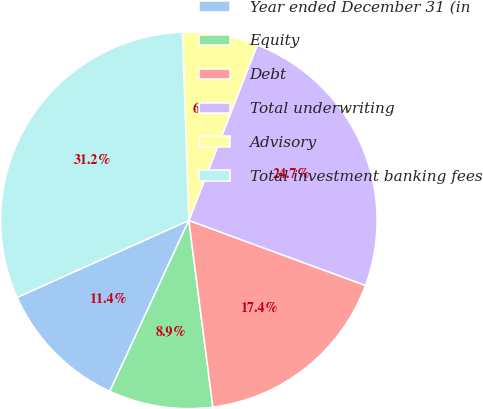<chart> <loc_0><loc_0><loc_500><loc_500><pie_chart><fcel>Year ended December 31 (in<fcel>Equity<fcel>Debt<fcel>Total underwriting<fcel>Advisory<fcel>Total investment banking fees<nl><fcel>11.4%<fcel>8.93%<fcel>17.35%<fcel>24.7%<fcel>6.46%<fcel>31.16%<nl></chart> 